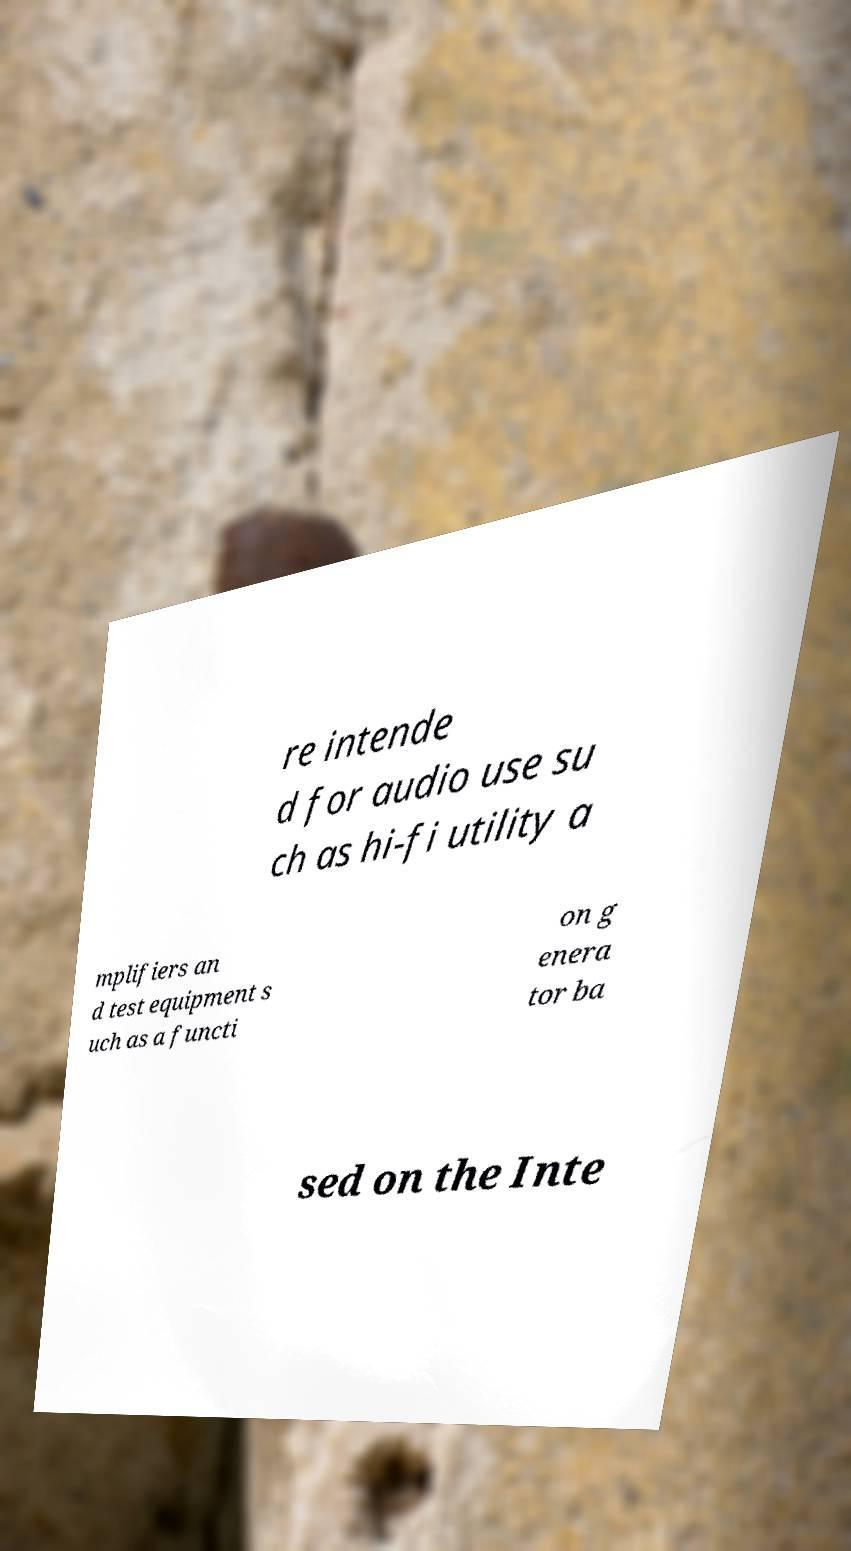There's text embedded in this image that I need extracted. Can you transcribe it verbatim? re intende d for audio use su ch as hi-fi utility a mplifiers an d test equipment s uch as a functi on g enera tor ba sed on the Inte 